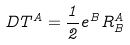Convert formula to latex. <formula><loc_0><loc_0><loc_500><loc_500>D T ^ { A } = \frac { 1 } { 2 } e ^ { B } R _ { B } ^ { A }</formula> 